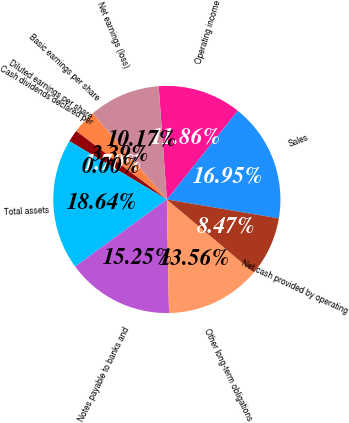<chart> <loc_0><loc_0><loc_500><loc_500><pie_chart><fcel>Sales<fcel>Operating income<fcel>Net earnings (loss)<fcel>Basic earnings per share<fcel>Diluted earnings per share<fcel>Cash dividends declared per<fcel>Total assets<fcel>Notes payable to banks and<fcel>Other long-term obligations<fcel>Net cash provided by operating<nl><fcel>16.95%<fcel>11.86%<fcel>10.17%<fcel>3.39%<fcel>1.7%<fcel>0.0%<fcel>18.64%<fcel>15.25%<fcel>13.56%<fcel>8.47%<nl></chart> 